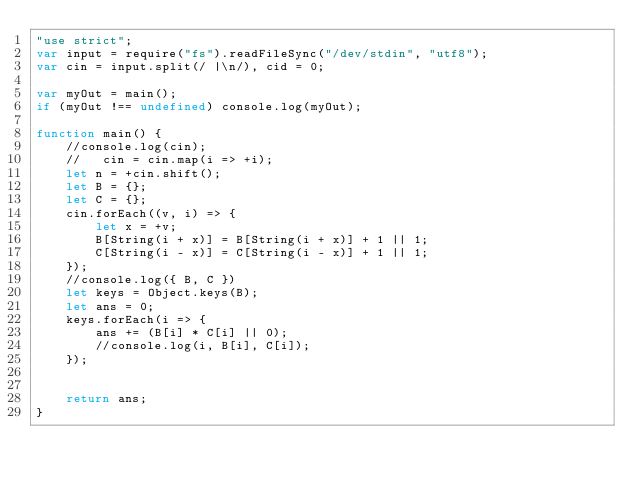<code> <loc_0><loc_0><loc_500><loc_500><_JavaScript_>"use strict";
var input = require("fs").readFileSync("/dev/stdin", "utf8");
var cin = input.split(/ |\n/), cid = 0;

var myOut = main();
if (myOut !== undefined) console.log(myOut);

function main() {
    //console.log(cin);
    //   cin = cin.map(i => +i);
    let n = +cin.shift();
    let B = {};
    let C = {};
    cin.forEach((v, i) => {
        let x = +v;
        B[String(i + x)] = B[String(i + x)] + 1 || 1;
        C[String(i - x)] = C[String(i - x)] + 1 || 1;
    });
    //console.log({ B, C })
    let keys = Object.keys(B);
    let ans = 0;
    keys.forEach(i => {
        ans += (B[i] * C[i] || 0);
        //console.log(i, B[i], C[i]);
    });


    return ans;
}</code> 